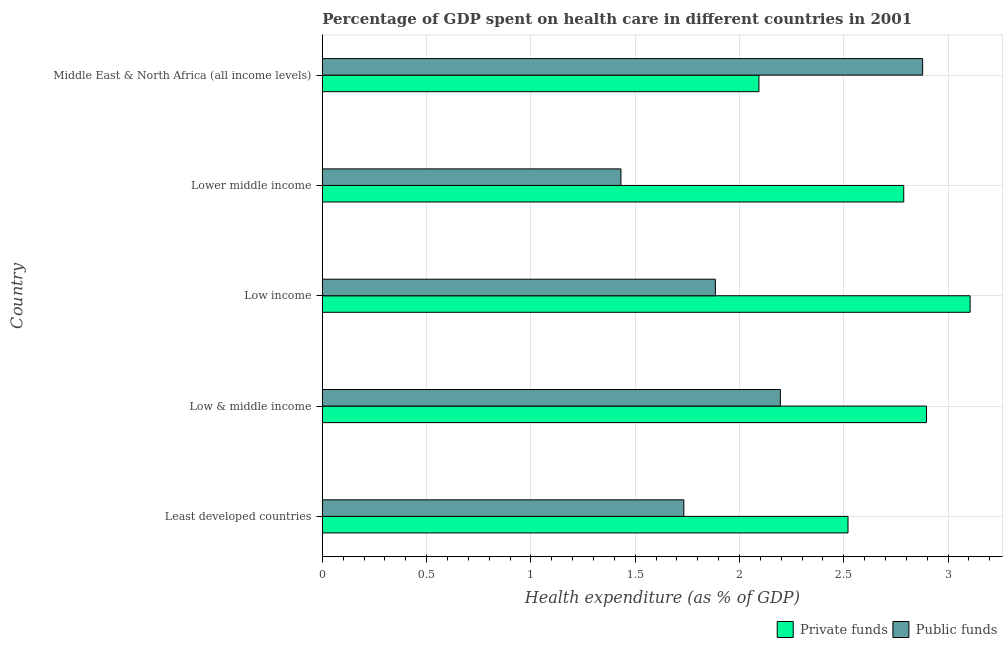How many different coloured bars are there?
Your answer should be very brief. 2. Are the number of bars per tick equal to the number of legend labels?
Your response must be concise. Yes. Are the number of bars on each tick of the Y-axis equal?
Make the answer very short. Yes. How many bars are there on the 4th tick from the top?
Provide a succinct answer. 2. How many bars are there on the 1st tick from the bottom?
Make the answer very short. 2. What is the label of the 1st group of bars from the top?
Your response must be concise. Middle East & North Africa (all income levels). What is the amount of private funds spent in healthcare in Low & middle income?
Ensure brevity in your answer.  2.9. Across all countries, what is the maximum amount of public funds spent in healthcare?
Your answer should be very brief. 2.88. Across all countries, what is the minimum amount of private funds spent in healthcare?
Make the answer very short. 2.09. In which country was the amount of private funds spent in healthcare minimum?
Your answer should be very brief. Middle East & North Africa (all income levels). What is the total amount of public funds spent in healthcare in the graph?
Ensure brevity in your answer.  10.12. What is the difference between the amount of private funds spent in healthcare in Least developed countries and that in Low income?
Provide a short and direct response. -0.58. What is the difference between the amount of private funds spent in healthcare in Least developed countries and the amount of public funds spent in healthcare in Middle East & North Africa (all income levels)?
Your answer should be compact. -0.36. What is the average amount of public funds spent in healthcare per country?
Your answer should be very brief. 2.02. What is the difference between the amount of public funds spent in healthcare and amount of private funds spent in healthcare in Low & middle income?
Give a very brief answer. -0.7. What is the ratio of the amount of private funds spent in healthcare in Least developed countries to that in Lower middle income?
Provide a succinct answer. 0.9. What is the difference between the highest and the second highest amount of public funds spent in healthcare?
Provide a succinct answer. 0.68. In how many countries, is the amount of public funds spent in healthcare greater than the average amount of public funds spent in healthcare taken over all countries?
Offer a very short reply. 2. Is the sum of the amount of public funds spent in healthcare in Lower middle income and Middle East & North Africa (all income levels) greater than the maximum amount of private funds spent in healthcare across all countries?
Your answer should be compact. Yes. What does the 2nd bar from the top in Low & middle income represents?
Give a very brief answer. Private funds. What does the 1st bar from the bottom in Low income represents?
Make the answer very short. Private funds. Does the graph contain any zero values?
Provide a short and direct response. No. Does the graph contain grids?
Your answer should be compact. Yes. How are the legend labels stacked?
Offer a very short reply. Horizontal. What is the title of the graph?
Give a very brief answer. Percentage of GDP spent on health care in different countries in 2001. What is the label or title of the X-axis?
Your answer should be very brief. Health expenditure (as % of GDP). What is the Health expenditure (as % of GDP) of Private funds in Least developed countries?
Provide a succinct answer. 2.52. What is the Health expenditure (as % of GDP) in Public funds in Least developed countries?
Your answer should be very brief. 1.73. What is the Health expenditure (as % of GDP) of Private funds in Low & middle income?
Your response must be concise. 2.9. What is the Health expenditure (as % of GDP) of Public funds in Low & middle income?
Provide a short and direct response. 2.2. What is the Health expenditure (as % of GDP) of Private funds in Low income?
Your answer should be compact. 3.11. What is the Health expenditure (as % of GDP) of Public funds in Low income?
Give a very brief answer. 1.88. What is the Health expenditure (as % of GDP) of Private funds in Lower middle income?
Offer a very short reply. 2.79. What is the Health expenditure (as % of GDP) in Public funds in Lower middle income?
Your answer should be very brief. 1.43. What is the Health expenditure (as % of GDP) of Private funds in Middle East & North Africa (all income levels)?
Your answer should be compact. 2.09. What is the Health expenditure (as % of GDP) in Public funds in Middle East & North Africa (all income levels)?
Offer a terse response. 2.88. Across all countries, what is the maximum Health expenditure (as % of GDP) in Private funds?
Your answer should be very brief. 3.11. Across all countries, what is the maximum Health expenditure (as % of GDP) of Public funds?
Provide a short and direct response. 2.88. Across all countries, what is the minimum Health expenditure (as % of GDP) of Private funds?
Keep it short and to the point. 2.09. Across all countries, what is the minimum Health expenditure (as % of GDP) in Public funds?
Your answer should be compact. 1.43. What is the total Health expenditure (as % of GDP) in Private funds in the graph?
Provide a short and direct response. 13.4. What is the total Health expenditure (as % of GDP) of Public funds in the graph?
Your answer should be very brief. 10.12. What is the difference between the Health expenditure (as % of GDP) of Private funds in Least developed countries and that in Low & middle income?
Your answer should be very brief. -0.38. What is the difference between the Health expenditure (as % of GDP) of Public funds in Least developed countries and that in Low & middle income?
Provide a short and direct response. -0.46. What is the difference between the Health expenditure (as % of GDP) in Private funds in Least developed countries and that in Low income?
Your response must be concise. -0.59. What is the difference between the Health expenditure (as % of GDP) of Public funds in Least developed countries and that in Low income?
Provide a short and direct response. -0.15. What is the difference between the Health expenditure (as % of GDP) of Private funds in Least developed countries and that in Lower middle income?
Make the answer very short. -0.27. What is the difference between the Health expenditure (as % of GDP) in Public funds in Least developed countries and that in Lower middle income?
Give a very brief answer. 0.3. What is the difference between the Health expenditure (as % of GDP) of Private funds in Least developed countries and that in Middle East & North Africa (all income levels)?
Provide a short and direct response. 0.43. What is the difference between the Health expenditure (as % of GDP) of Public funds in Least developed countries and that in Middle East & North Africa (all income levels)?
Offer a terse response. -1.14. What is the difference between the Health expenditure (as % of GDP) of Private funds in Low & middle income and that in Low income?
Provide a short and direct response. -0.21. What is the difference between the Health expenditure (as % of GDP) in Public funds in Low & middle income and that in Low income?
Make the answer very short. 0.31. What is the difference between the Health expenditure (as % of GDP) of Private funds in Low & middle income and that in Lower middle income?
Your response must be concise. 0.11. What is the difference between the Health expenditure (as % of GDP) of Public funds in Low & middle income and that in Lower middle income?
Give a very brief answer. 0.76. What is the difference between the Health expenditure (as % of GDP) in Private funds in Low & middle income and that in Middle East & North Africa (all income levels)?
Give a very brief answer. 0.8. What is the difference between the Health expenditure (as % of GDP) in Public funds in Low & middle income and that in Middle East & North Africa (all income levels)?
Make the answer very short. -0.68. What is the difference between the Health expenditure (as % of GDP) in Private funds in Low income and that in Lower middle income?
Provide a succinct answer. 0.32. What is the difference between the Health expenditure (as % of GDP) of Public funds in Low income and that in Lower middle income?
Give a very brief answer. 0.45. What is the difference between the Health expenditure (as % of GDP) of Private funds in Low income and that in Middle East & North Africa (all income levels)?
Provide a succinct answer. 1.01. What is the difference between the Health expenditure (as % of GDP) of Public funds in Low income and that in Middle East & North Africa (all income levels)?
Ensure brevity in your answer.  -0.99. What is the difference between the Health expenditure (as % of GDP) of Private funds in Lower middle income and that in Middle East & North Africa (all income levels)?
Provide a succinct answer. 0.69. What is the difference between the Health expenditure (as % of GDP) in Public funds in Lower middle income and that in Middle East & North Africa (all income levels)?
Keep it short and to the point. -1.45. What is the difference between the Health expenditure (as % of GDP) of Private funds in Least developed countries and the Health expenditure (as % of GDP) of Public funds in Low & middle income?
Offer a very short reply. 0.32. What is the difference between the Health expenditure (as % of GDP) of Private funds in Least developed countries and the Health expenditure (as % of GDP) of Public funds in Low income?
Ensure brevity in your answer.  0.64. What is the difference between the Health expenditure (as % of GDP) of Private funds in Least developed countries and the Health expenditure (as % of GDP) of Public funds in Lower middle income?
Give a very brief answer. 1.09. What is the difference between the Health expenditure (as % of GDP) in Private funds in Least developed countries and the Health expenditure (as % of GDP) in Public funds in Middle East & North Africa (all income levels)?
Ensure brevity in your answer.  -0.36. What is the difference between the Health expenditure (as % of GDP) of Private funds in Low & middle income and the Health expenditure (as % of GDP) of Public funds in Low income?
Your answer should be very brief. 1.01. What is the difference between the Health expenditure (as % of GDP) of Private funds in Low & middle income and the Health expenditure (as % of GDP) of Public funds in Lower middle income?
Your answer should be compact. 1.46. What is the difference between the Health expenditure (as % of GDP) of Private funds in Low & middle income and the Health expenditure (as % of GDP) of Public funds in Middle East & North Africa (all income levels)?
Make the answer very short. 0.02. What is the difference between the Health expenditure (as % of GDP) of Private funds in Low income and the Health expenditure (as % of GDP) of Public funds in Lower middle income?
Keep it short and to the point. 1.67. What is the difference between the Health expenditure (as % of GDP) of Private funds in Low income and the Health expenditure (as % of GDP) of Public funds in Middle East & North Africa (all income levels)?
Offer a very short reply. 0.23. What is the difference between the Health expenditure (as % of GDP) in Private funds in Lower middle income and the Health expenditure (as % of GDP) in Public funds in Middle East & North Africa (all income levels)?
Provide a short and direct response. -0.09. What is the average Health expenditure (as % of GDP) of Private funds per country?
Keep it short and to the point. 2.68. What is the average Health expenditure (as % of GDP) in Public funds per country?
Provide a short and direct response. 2.02. What is the difference between the Health expenditure (as % of GDP) of Private funds and Health expenditure (as % of GDP) of Public funds in Least developed countries?
Offer a very short reply. 0.79. What is the difference between the Health expenditure (as % of GDP) in Private funds and Health expenditure (as % of GDP) in Public funds in Low & middle income?
Offer a terse response. 0.7. What is the difference between the Health expenditure (as % of GDP) in Private funds and Health expenditure (as % of GDP) in Public funds in Low income?
Provide a short and direct response. 1.22. What is the difference between the Health expenditure (as % of GDP) of Private funds and Health expenditure (as % of GDP) of Public funds in Lower middle income?
Your answer should be very brief. 1.36. What is the difference between the Health expenditure (as % of GDP) in Private funds and Health expenditure (as % of GDP) in Public funds in Middle East & North Africa (all income levels)?
Give a very brief answer. -0.78. What is the ratio of the Health expenditure (as % of GDP) of Private funds in Least developed countries to that in Low & middle income?
Give a very brief answer. 0.87. What is the ratio of the Health expenditure (as % of GDP) of Public funds in Least developed countries to that in Low & middle income?
Give a very brief answer. 0.79. What is the ratio of the Health expenditure (as % of GDP) in Private funds in Least developed countries to that in Low income?
Make the answer very short. 0.81. What is the ratio of the Health expenditure (as % of GDP) in Public funds in Least developed countries to that in Low income?
Provide a short and direct response. 0.92. What is the ratio of the Health expenditure (as % of GDP) in Private funds in Least developed countries to that in Lower middle income?
Your answer should be compact. 0.9. What is the ratio of the Health expenditure (as % of GDP) of Public funds in Least developed countries to that in Lower middle income?
Your response must be concise. 1.21. What is the ratio of the Health expenditure (as % of GDP) of Private funds in Least developed countries to that in Middle East & North Africa (all income levels)?
Offer a very short reply. 1.2. What is the ratio of the Health expenditure (as % of GDP) in Public funds in Least developed countries to that in Middle East & North Africa (all income levels)?
Make the answer very short. 0.6. What is the ratio of the Health expenditure (as % of GDP) in Private funds in Low & middle income to that in Low income?
Ensure brevity in your answer.  0.93. What is the ratio of the Health expenditure (as % of GDP) in Public funds in Low & middle income to that in Low income?
Provide a short and direct response. 1.17. What is the ratio of the Health expenditure (as % of GDP) in Private funds in Low & middle income to that in Lower middle income?
Your answer should be compact. 1.04. What is the ratio of the Health expenditure (as % of GDP) in Public funds in Low & middle income to that in Lower middle income?
Your answer should be compact. 1.53. What is the ratio of the Health expenditure (as % of GDP) of Private funds in Low & middle income to that in Middle East & North Africa (all income levels)?
Provide a succinct answer. 1.38. What is the ratio of the Health expenditure (as % of GDP) in Public funds in Low & middle income to that in Middle East & North Africa (all income levels)?
Offer a terse response. 0.76. What is the ratio of the Health expenditure (as % of GDP) in Private funds in Low income to that in Lower middle income?
Make the answer very short. 1.11. What is the ratio of the Health expenditure (as % of GDP) of Public funds in Low income to that in Lower middle income?
Your response must be concise. 1.32. What is the ratio of the Health expenditure (as % of GDP) in Private funds in Low income to that in Middle East & North Africa (all income levels)?
Keep it short and to the point. 1.48. What is the ratio of the Health expenditure (as % of GDP) in Public funds in Low income to that in Middle East & North Africa (all income levels)?
Ensure brevity in your answer.  0.65. What is the ratio of the Health expenditure (as % of GDP) in Private funds in Lower middle income to that in Middle East & North Africa (all income levels)?
Keep it short and to the point. 1.33. What is the ratio of the Health expenditure (as % of GDP) in Public funds in Lower middle income to that in Middle East & North Africa (all income levels)?
Make the answer very short. 0.5. What is the difference between the highest and the second highest Health expenditure (as % of GDP) of Private funds?
Ensure brevity in your answer.  0.21. What is the difference between the highest and the second highest Health expenditure (as % of GDP) of Public funds?
Offer a terse response. 0.68. What is the difference between the highest and the lowest Health expenditure (as % of GDP) of Private funds?
Ensure brevity in your answer.  1.01. What is the difference between the highest and the lowest Health expenditure (as % of GDP) in Public funds?
Your response must be concise. 1.45. 